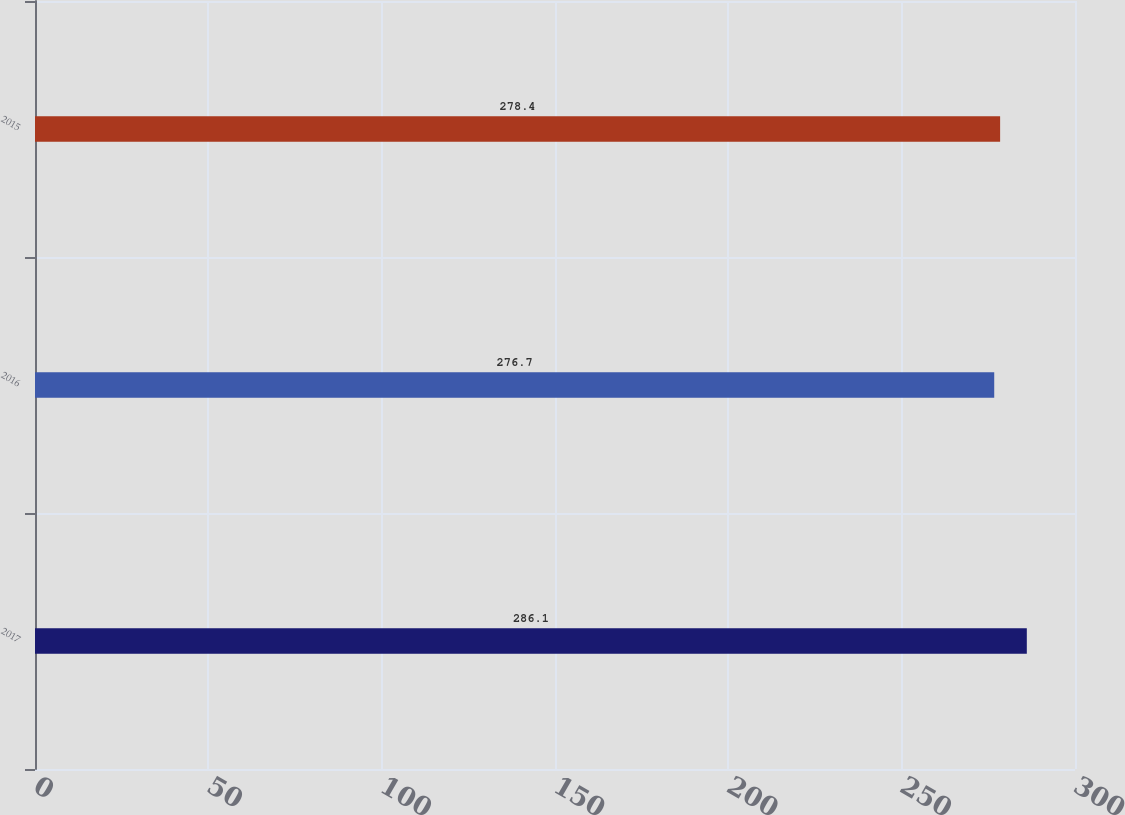<chart> <loc_0><loc_0><loc_500><loc_500><bar_chart><fcel>2017<fcel>2016<fcel>2015<nl><fcel>286.1<fcel>276.7<fcel>278.4<nl></chart> 